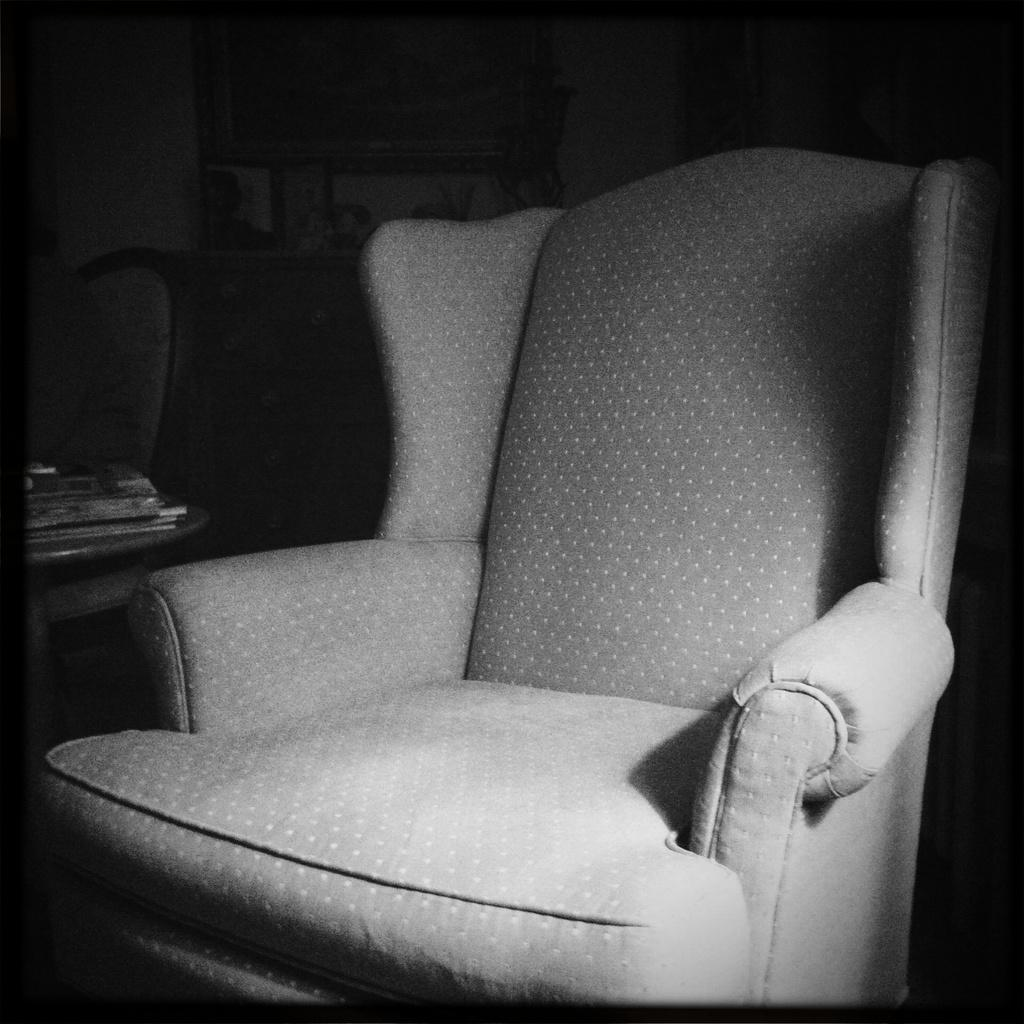What is the color scheme of the image? The image is black and white. What type of furniture is present in the image? There is a chair in the image. Can you describe the background of the image? There is a chair with books in the background of the image. What type of rhythm can be heard in the image? There is no sound or rhythm present in the image, as it is a still, black and white photograph. 